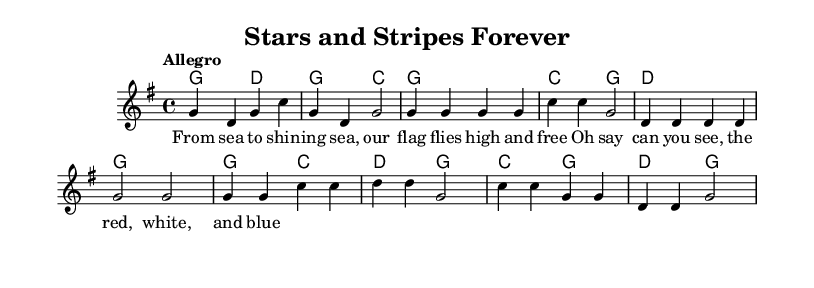What is the key signature of this music? The key signature indicated for the piece is G major, which has one sharp (F#). This is shown in the first line of the music notation.
Answer: G major What is the time signature of this music? The time signature is 4/4, commonly seen as four beats in each measure. It is specified at the beginning of the score, indicating the rhythmic structure of the piece.
Answer: 4/4 What is the tempo marking for this piece? The tempo marking given is "Allegro," which suggests a fast and lively pace. This marking is found in the introductory section of the music notation.
Answer: Allegro How many measures are in the verse section of this piece? The verse section consists of eight measures. This can be determined by counting the number of bar lines in the melody part corresponding to the verse lyrics represented in the music score.
Answer: 8 Which chord indicates the intro of the piece? The chords indicating the intro are G and D. This is clarified in the chord section of the music, with these chords appearing before the melody begins.
Answer: G, D What is the last chord used in the score? The last chord used in the score is G. This is evident from the final chord indicated in the harmony section, suggesting resolution to the tonic chord at the end of the piece.
Answer: G What lyrics correspond to the melody in the score? The lyrics corresponding to the melody are "From sea to shining sea, our flag flies high and free." This can be seen paired directly with the melody notes in the lyrics section of the score.
Answer: From sea to shining sea, our flag flies high and free 